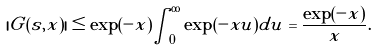<formula> <loc_0><loc_0><loc_500><loc_500>| G ( s , x ) | \leq \exp ( - x ) \int _ { 0 } ^ { \infty } \exp ( - x u ) d u = \frac { \exp ( - x ) } { x } .</formula> 